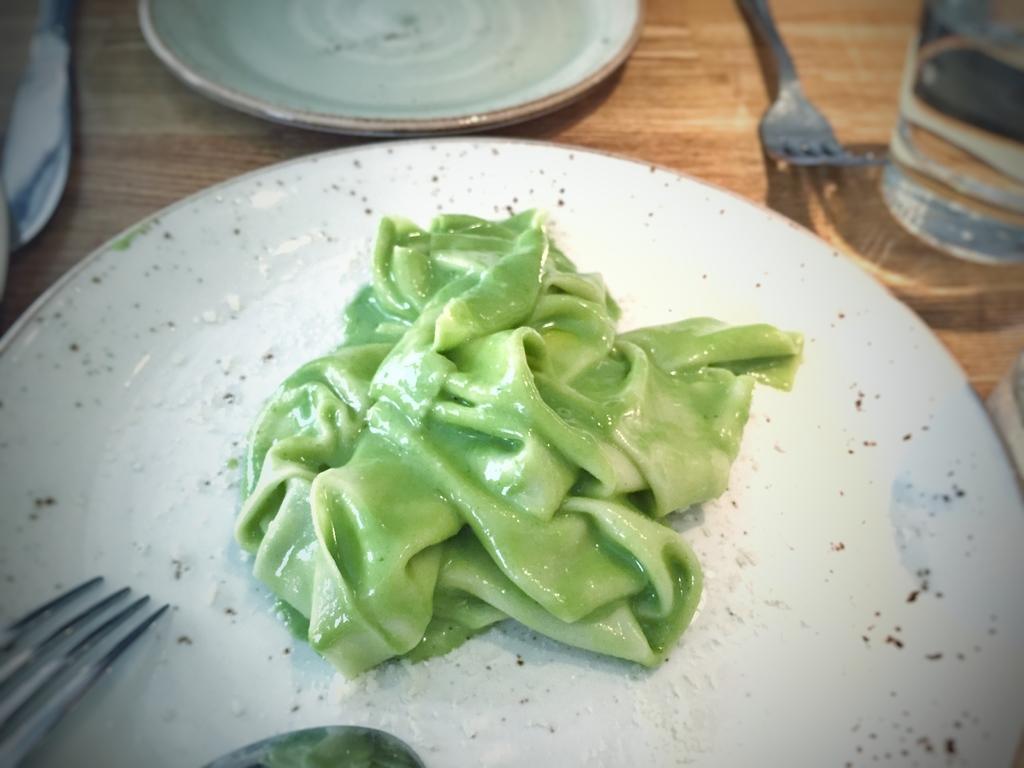How would you summarize this image in a sentence or two? In this image I can see two plates in the centre I can see a green colour thing on the plate. On the top right side of this image I can see a fork and a glass. On the left side of this image I can see a knife and a fork on the plate. 